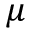<formula> <loc_0><loc_0><loc_500><loc_500>\mu</formula> 